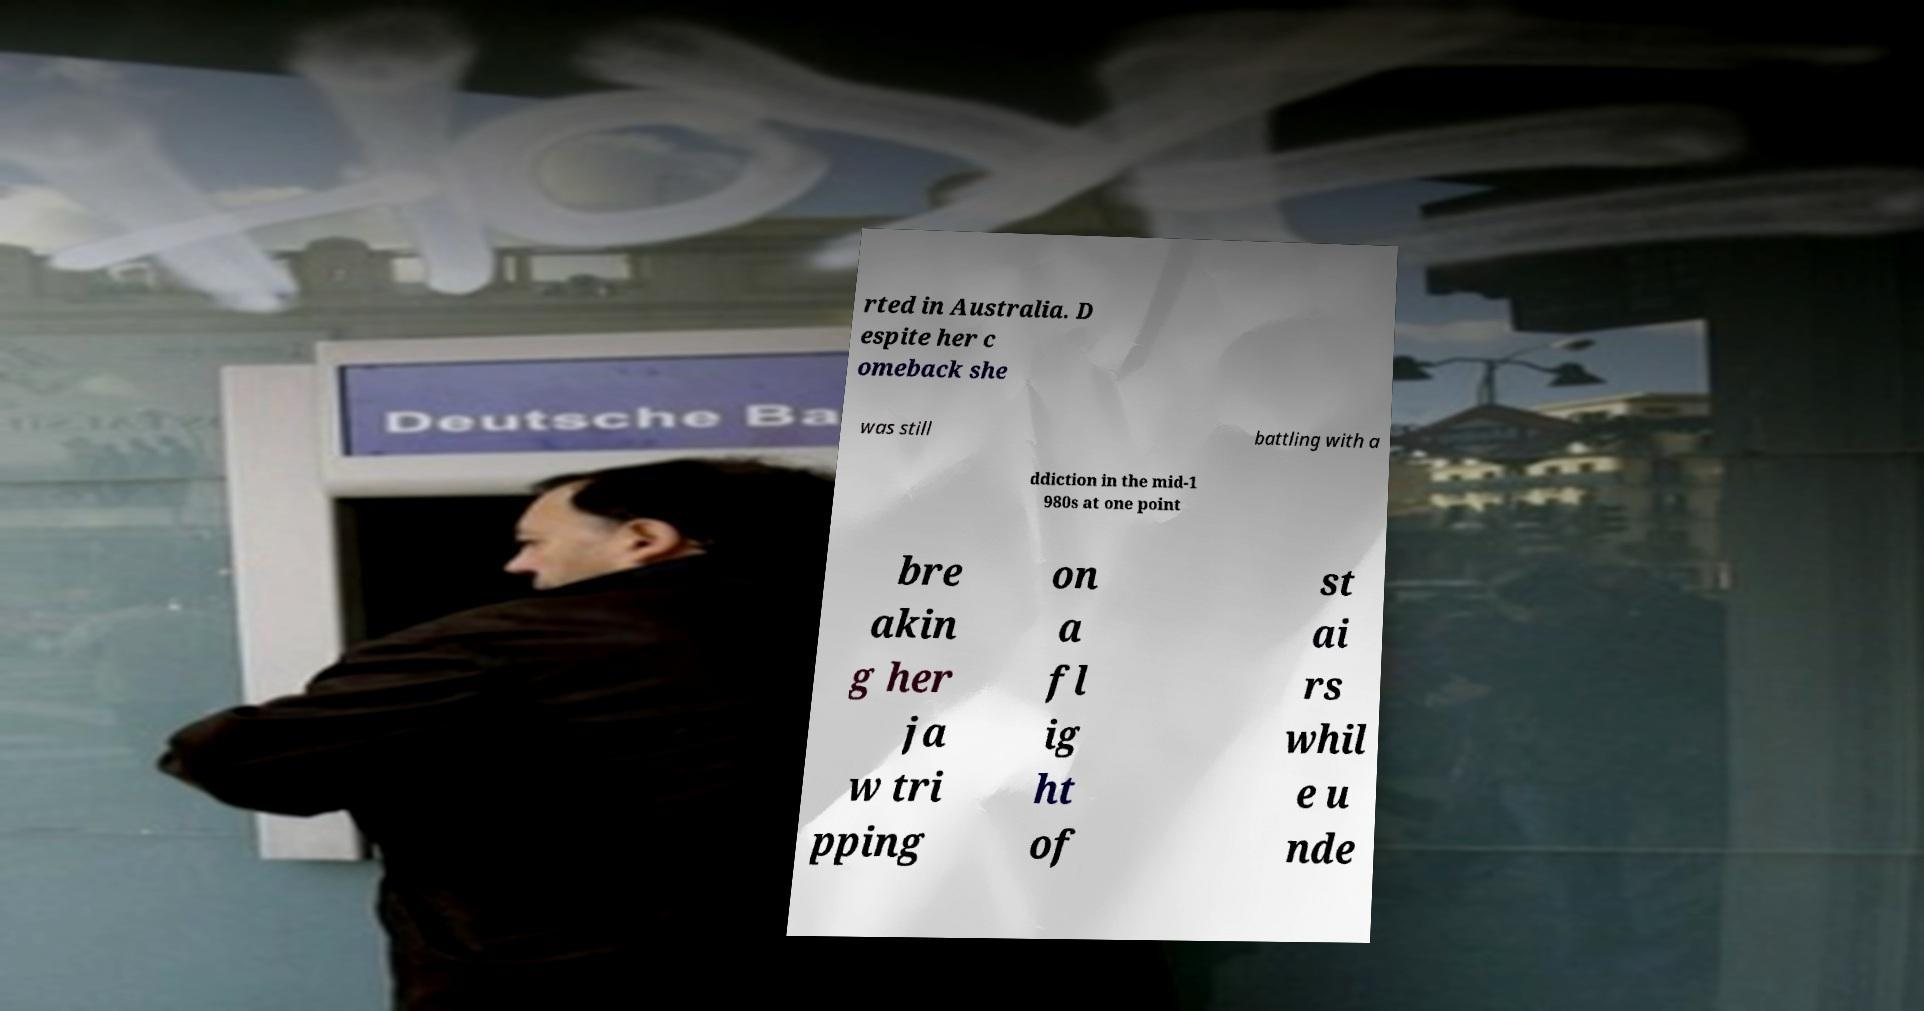Please identify and transcribe the text found in this image. rted in Australia. D espite her c omeback she was still battling with a ddiction in the mid-1 980s at one point bre akin g her ja w tri pping on a fl ig ht of st ai rs whil e u nde 